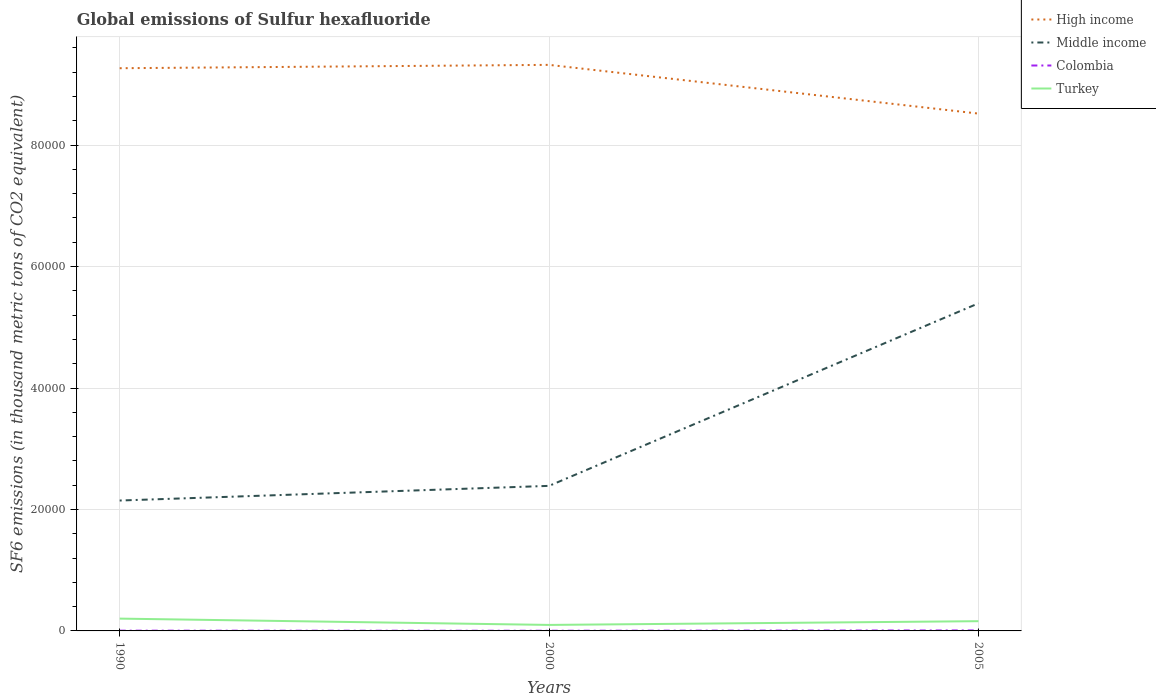Across all years, what is the maximum global emissions of Sulfur hexafluoride in High income?
Provide a short and direct response. 8.52e+04. In which year was the global emissions of Sulfur hexafluoride in Colombia maximum?
Offer a terse response. 2000. What is the total global emissions of Sulfur hexafluoride in Colombia in the graph?
Your answer should be compact. 13.5. What is the difference between the highest and the second highest global emissions of Sulfur hexafluoride in Turkey?
Provide a short and direct response. 1037.9. What is the difference between the highest and the lowest global emissions of Sulfur hexafluoride in Turkey?
Your answer should be compact. 2. What is the difference between two consecutive major ticks on the Y-axis?
Make the answer very short. 2.00e+04. Does the graph contain any zero values?
Offer a terse response. No. Does the graph contain grids?
Give a very brief answer. Yes. How are the legend labels stacked?
Provide a short and direct response. Vertical. What is the title of the graph?
Make the answer very short. Global emissions of Sulfur hexafluoride. Does "Vanuatu" appear as one of the legend labels in the graph?
Ensure brevity in your answer.  No. What is the label or title of the X-axis?
Ensure brevity in your answer.  Years. What is the label or title of the Y-axis?
Make the answer very short. SF6 emissions (in thousand metric tons of CO2 equivalent). What is the SF6 emissions (in thousand metric tons of CO2 equivalent) of High income in 1990?
Offer a terse response. 9.27e+04. What is the SF6 emissions (in thousand metric tons of CO2 equivalent) of Middle income in 1990?
Give a very brief answer. 2.15e+04. What is the SF6 emissions (in thousand metric tons of CO2 equivalent) in Colombia in 1990?
Offer a terse response. 41.7. What is the SF6 emissions (in thousand metric tons of CO2 equivalent) in Turkey in 1990?
Your answer should be very brief. 2027.1. What is the SF6 emissions (in thousand metric tons of CO2 equivalent) in High income in 2000?
Your answer should be compact. 9.32e+04. What is the SF6 emissions (in thousand metric tons of CO2 equivalent) of Middle income in 2000?
Offer a very short reply. 2.39e+04. What is the SF6 emissions (in thousand metric tons of CO2 equivalent) in Colombia in 2000?
Offer a very short reply. 28.2. What is the SF6 emissions (in thousand metric tons of CO2 equivalent) of Turkey in 2000?
Your answer should be very brief. 989.2. What is the SF6 emissions (in thousand metric tons of CO2 equivalent) in High income in 2005?
Offer a very short reply. 8.52e+04. What is the SF6 emissions (in thousand metric tons of CO2 equivalent) in Middle income in 2005?
Make the answer very short. 5.39e+04. What is the SF6 emissions (in thousand metric tons of CO2 equivalent) of Colombia in 2005?
Provide a short and direct response. 82.9. What is the SF6 emissions (in thousand metric tons of CO2 equivalent) of Turkey in 2005?
Ensure brevity in your answer.  1602.2. Across all years, what is the maximum SF6 emissions (in thousand metric tons of CO2 equivalent) in High income?
Your response must be concise. 9.32e+04. Across all years, what is the maximum SF6 emissions (in thousand metric tons of CO2 equivalent) of Middle income?
Your answer should be very brief. 5.39e+04. Across all years, what is the maximum SF6 emissions (in thousand metric tons of CO2 equivalent) in Colombia?
Give a very brief answer. 82.9. Across all years, what is the maximum SF6 emissions (in thousand metric tons of CO2 equivalent) in Turkey?
Your answer should be compact. 2027.1. Across all years, what is the minimum SF6 emissions (in thousand metric tons of CO2 equivalent) in High income?
Make the answer very short. 8.52e+04. Across all years, what is the minimum SF6 emissions (in thousand metric tons of CO2 equivalent) of Middle income?
Your answer should be very brief. 2.15e+04. Across all years, what is the minimum SF6 emissions (in thousand metric tons of CO2 equivalent) of Colombia?
Ensure brevity in your answer.  28.2. Across all years, what is the minimum SF6 emissions (in thousand metric tons of CO2 equivalent) of Turkey?
Offer a terse response. 989.2. What is the total SF6 emissions (in thousand metric tons of CO2 equivalent) of High income in the graph?
Keep it short and to the point. 2.71e+05. What is the total SF6 emissions (in thousand metric tons of CO2 equivalent) of Middle income in the graph?
Offer a terse response. 9.93e+04. What is the total SF6 emissions (in thousand metric tons of CO2 equivalent) in Colombia in the graph?
Offer a terse response. 152.8. What is the total SF6 emissions (in thousand metric tons of CO2 equivalent) of Turkey in the graph?
Offer a terse response. 4618.5. What is the difference between the SF6 emissions (in thousand metric tons of CO2 equivalent) in High income in 1990 and that in 2000?
Provide a succinct answer. -551.2. What is the difference between the SF6 emissions (in thousand metric tons of CO2 equivalent) of Middle income in 1990 and that in 2000?
Your answer should be very brief. -2413.4. What is the difference between the SF6 emissions (in thousand metric tons of CO2 equivalent) of Turkey in 1990 and that in 2000?
Ensure brevity in your answer.  1037.9. What is the difference between the SF6 emissions (in thousand metric tons of CO2 equivalent) in High income in 1990 and that in 2005?
Offer a very short reply. 7470.39. What is the difference between the SF6 emissions (in thousand metric tons of CO2 equivalent) in Middle income in 1990 and that in 2005?
Make the answer very short. -3.25e+04. What is the difference between the SF6 emissions (in thousand metric tons of CO2 equivalent) of Colombia in 1990 and that in 2005?
Keep it short and to the point. -41.2. What is the difference between the SF6 emissions (in thousand metric tons of CO2 equivalent) of Turkey in 1990 and that in 2005?
Your answer should be compact. 424.9. What is the difference between the SF6 emissions (in thousand metric tons of CO2 equivalent) in High income in 2000 and that in 2005?
Provide a succinct answer. 8021.59. What is the difference between the SF6 emissions (in thousand metric tons of CO2 equivalent) of Middle income in 2000 and that in 2005?
Ensure brevity in your answer.  -3.01e+04. What is the difference between the SF6 emissions (in thousand metric tons of CO2 equivalent) in Colombia in 2000 and that in 2005?
Offer a terse response. -54.7. What is the difference between the SF6 emissions (in thousand metric tons of CO2 equivalent) of Turkey in 2000 and that in 2005?
Keep it short and to the point. -613. What is the difference between the SF6 emissions (in thousand metric tons of CO2 equivalent) in High income in 1990 and the SF6 emissions (in thousand metric tons of CO2 equivalent) in Middle income in 2000?
Give a very brief answer. 6.88e+04. What is the difference between the SF6 emissions (in thousand metric tons of CO2 equivalent) in High income in 1990 and the SF6 emissions (in thousand metric tons of CO2 equivalent) in Colombia in 2000?
Ensure brevity in your answer.  9.26e+04. What is the difference between the SF6 emissions (in thousand metric tons of CO2 equivalent) in High income in 1990 and the SF6 emissions (in thousand metric tons of CO2 equivalent) in Turkey in 2000?
Your answer should be very brief. 9.17e+04. What is the difference between the SF6 emissions (in thousand metric tons of CO2 equivalent) in Middle income in 1990 and the SF6 emissions (in thousand metric tons of CO2 equivalent) in Colombia in 2000?
Ensure brevity in your answer.  2.14e+04. What is the difference between the SF6 emissions (in thousand metric tons of CO2 equivalent) of Middle income in 1990 and the SF6 emissions (in thousand metric tons of CO2 equivalent) of Turkey in 2000?
Your answer should be very brief. 2.05e+04. What is the difference between the SF6 emissions (in thousand metric tons of CO2 equivalent) in Colombia in 1990 and the SF6 emissions (in thousand metric tons of CO2 equivalent) in Turkey in 2000?
Your response must be concise. -947.5. What is the difference between the SF6 emissions (in thousand metric tons of CO2 equivalent) of High income in 1990 and the SF6 emissions (in thousand metric tons of CO2 equivalent) of Middle income in 2005?
Offer a very short reply. 3.87e+04. What is the difference between the SF6 emissions (in thousand metric tons of CO2 equivalent) of High income in 1990 and the SF6 emissions (in thousand metric tons of CO2 equivalent) of Colombia in 2005?
Your answer should be very brief. 9.26e+04. What is the difference between the SF6 emissions (in thousand metric tons of CO2 equivalent) in High income in 1990 and the SF6 emissions (in thousand metric tons of CO2 equivalent) in Turkey in 2005?
Offer a terse response. 9.11e+04. What is the difference between the SF6 emissions (in thousand metric tons of CO2 equivalent) in Middle income in 1990 and the SF6 emissions (in thousand metric tons of CO2 equivalent) in Colombia in 2005?
Keep it short and to the point. 2.14e+04. What is the difference between the SF6 emissions (in thousand metric tons of CO2 equivalent) of Middle income in 1990 and the SF6 emissions (in thousand metric tons of CO2 equivalent) of Turkey in 2005?
Make the answer very short. 1.99e+04. What is the difference between the SF6 emissions (in thousand metric tons of CO2 equivalent) in Colombia in 1990 and the SF6 emissions (in thousand metric tons of CO2 equivalent) in Turkey in 2005?
Offer a terse response. -1560.5. What is the difference between the SF6 emissions (in thousand metric tons of CO2 equivalent) of High income in 2000 and the SF6 emissions (in thousand metric tons of CO2 equivalent) of Middle income in 2005?
Your answer should be compact. 3.93e+04. What is the difference between the SF6 emissions (in thousand metric tons of CO2 equivalent) of High income in 2000 and the SF6 emissions (in thousand metric tons of CO2 equivalent) of Colombia in 2005?
Give a very brief answer. 9.31e+04. What is the difference between the SF6 emissions (in thousand metric tons of CO2 equivalent) in High income in 2000 and the SF6 emissions (in thousand metric tons of CO2 equivalent) in Turkey in 2005?
Offer a terse response. 9.16e+04. What is the difference between the SF6 emissions (in thousand metric tons of CO2 equivalent) of Middle income in 2000 and the SF6 emissions (in thousand metric tons of CO2 equivalent) of Colombia in 2005?
Keep it short and to the point. 2.38e+04. What is the difference between the SF6 emissions (in thousand metric tons of CO2 equivalent) of Middle income in 2000 and the SF6 emissions (in thousand metric tons of CO2 equivalent) of Turkey in 2005?
Ensure brevity in your answer.  2.23e+04. What is the difference between the SF6 emissions (in thousand metric tons of CO2 equivalent) of Colombia in 2000 and the SF6 emissions (in thousand metric tons of CO2 equivalent) of Turkey in 2005?
Your response must be concise. -1574. What is the average SF6 emissions (in thousand metric tons of CO2 equivalent) of High income per year?
Offer a terse response. 9.04e+04. What is the average SF6 emissions (in thousand metric tons of CO2 equivalent) in Middle income per year?
Offer a terse response. 3.31e+04. What is the average SF6 emissions (in thousand metric tons of CO2 equivalent) in Colombia per year?
Ensure brevity in your answer.  50.93. What is the average SF6 emissions (in thousand metric tons of CO2 equivalent) in Turkey per year?
Your answer should be compact. 1539.5. In the year 1990, what is the difference between the SF6 emissions (in thousand metric tons of CO2 equivalent) in High income and SF6 emissions (in thousand metric tons of CO2 equivalent) in Middle income?
Offer a very short reply. 7.12e+04. In the year 1990, what is the difference between the SF6 emissions (in thousand metric tons of CO2 equivalent) of High income and SF6 emissions (in thousand metric tons of CO2 equivalent) of Colombia?
Provide a short and direct response. 9.26e+04. In the year 1990, what is the difference between the SF6 emissions (in thousand metric tons of CO2 equivalent) of High income and SF6 emissions (in thousand metric tons of CO2 equivalent) of Turkey?
Your answer should be compact. 9.06e+04. In the year 1990, what is the difference between the SF6 emissions (in thousand metric tons of CO2 equivalent) of Middle income and SF6 emissions (in thousand metric tons of CO2 equivalent) of Colombia?
Ensure brevity in your answer.  2.14e+04. In the year 1990, what is the difference between the SF6 emissions (in thousand metric tons of CO2 equivalent) of Middle income and SF6 emissions (in thousand metric tons of CO2 equivalent) of Turkey?
Your answer should be very brief. 1.94e+04. In the year 1990, what is the difference between the SF6 emissions (in thousand metric tons of CO2 equivalent) of Colombia and SF6 emissions (in thousand metric tons of CO2 equivalent) of Turkey?
Offer a terse response. -1985.4. In the year 2000, what is the difference between the SF6 emissions (in thousand metric tons of CO2 equivalent) in High income and SF6 emissions (in thousand metric tons of CO2 equivalent) in Middle income?
Provide a succinct answer. 6.93e+04. In the year 2000, what is the difference between the SF6 emissions (in thousand metric tons of CO2 equivalent) in High income and SF6 emissions (in thousand metric tons of CO2 equivalent) in Colombia?
Your answer should be compact. 9.32e+04. In the year 2000, what is the difference between the SF6 emissions (in thousand metric tons of CO2 equivalent) in High income and SF6 emissions (in thousand metric tons of CO2 equivalent) in Turkey?
Make the answer very short. 9.22e+04. In the year 2000, what is the difference between the SF6 emissions (in thousand metric tons of CO2 equivalent) of Middle income and SF6 emissions (in thousand metric tons of CO2 equivalent) of Colombia?
Make the answer very short. 2.39e+04. In the year 2000, what is the difference between the SF6 emissions (in thousand metric tons of CO2 equivalent) in Middle income and SF6 emissions (in thousand metric tons of CO2 equivalent) in Turkey?
Your answer should be very brief. 2.29e+04. In the year 2000, what is the difference between the SF6 emissions (in thousand metric tons of CO2 equivalent) in Colombia and SF6 emissions (in thousand metric tons of CO2 equivalent) in Turkey?
Offer a terse response. -961. In the year 2005, what is the difference between the SF6 emissions (in thousand metric tons of CO2 equivalent) of High income and SF6 emissions (in thousand metric tons of CO2 equivalent) of Middle income?
Give a very brief answer. 3.12e+04. In the year 2005, what is the difference between the SF6 emissions (in thousand metric tons of CO2 equivalent) of High income and SF6 emissions (in thousand metric tons of CO2 equivalent) of Colombia?
Your response must be concise. 8.51e+04. In the year 2005, what is the difference between the SF6 emissions (in thousand metric tons of CO2 equivalent) of High income and SF6 emissions (in thousand metric tons of CO2 equivalent) of Turkey?
Your answer should be compact. 8.36e+04. In the year 2005, what is the difference between the SF6 emissions (in thousand metric tons of CO2 equivalent) in Middle income and SF6 emissions (in thousand metric tons of CO2 equivalent) in Colombia?
Make the answer very short. 5.39e+04. In the year 2005, what is the difference between the SF6 emissions (in thousand metric tons of CO2 equivalent) in Middle income and SF6 emissions (in thousand metric tons of CO2 equivalent) in Turkey?
Give a very brief answer. 5.23e+04. In the year 2005, what is the difference between the SF6 emissions (in thousand metric tons of CO2 equivalent) of Colombia and SF6 emissions (in thousand metric tons of CO2 equivalent) of Turkey?
Your answer should be very brief. -1519.3. What is the ratio of the SF6 emissions (in thousand metric tons of CO2 equivalent) in High income in 1990 to that in 2000?
Make the answer very short. 0.99. What is the ratio of the SF6 emissions (in thousand metric tons of CO2 equivalent) of Middle income in 1990 to that in 2000?
Offer a terse response. 0.9. What is the ratio of the SF6 emissions (in thousand metric tons of CO2 equivalent) in Colombia in 1990 to that in 2000?
Keep it short and to the point. 1.48. What is the ratio of the SF6 emissions (in thousand metric tons of CO2 equivalent) of Turkey in 1990 to that in 2000?
Provide a succinct answer. 2.05. What is the ratio of the SF6 emissions (in thousand metric tons of CO2 equivalent) of High income in 1990 to that in 2005?
Offer a terse response. 1.09. What is the ratio of the SF6 emissions (in thousand metric tons of CO2 equivalent) of Middle income in 1990 to that in 2005?
Your answer should be very brief. 0.4. What is the ratio of the SF6 emissions (in thousand metric tons of CO2 equivalent) in Colombia in 1990 to that in 2005?
Ensure brevity in your answer.  0.5. What is the ratio of the SF6 emissions (in thousand metric tons of CO2 equivalent) of Turkey in 1990 to that in 2005?
Give a very brief answer. 1.27. What is the ratio of the SF6 emissions (in thousand metric tons of CO2 equivalent) of High income in 2000 to that in 2005?
Ensure brevity in your answer.  1.09. What is the ratio of the SF6 emissions (in thousand metric tons of CO2 equivalent) of Middle income in 2000 to that in 2005?
Your answer should be compact. 0.44. What is the ratio of the SF6 emissions (in thousand metric tons of CO2 equivalent) in Colombia in 2000 to that in 2005?
Offer a terse response. 0.34. What is the ratio of the SF6 emissions (in thousand metric tons of CO2 equivalent) of Turkey in 2000 to that in 2005?
Offer a terse response. 0.62. What is the difference between the highest and the second highest SF6 emissions (in thousand metric tons of CO2 equivalent) in High income?
Your response must be concise. 551.2. What is the difference between the highest and the second highest SF6 emissions (in thousand metric tons of CO2 equivalent) of Middle income?
Provide a succinct answer. 3.01e+04. What is the difference between the highest and the second highest SF6 emissions (in thousand metric tons of CO2 equivalent) in Colombia?
Keep it short and to the point. 41.2. What is the difference between the highest and the second highest SF6 emissions (in thousand metric tons of CO2 equivalent) in Turkey?
Keep it short and to the point. 424.9. What is the difference between the highest and the lowest SF6 emissions (in thousand metric tons of CO2 equivalent) of High income?
Offer a terse response. 8021.59. What is the difference between the highest and the lowest SF6 emissions (in thousand metric tons of CO2 equivalent) of Middle income?
Keep it short and to the point. 3.25e+04. What is the difference between the highest and the lowest SF6 emissions (in thousand metric tons of CO2 equivalent) of Colombia?
Offer a very short reply. 54.7. What is the difference between the highest and the lowest SF6 emissions (in thousand metric tons of CO2 equivalent) in Turkey?
Provide a short and direct response. 1037.9. 